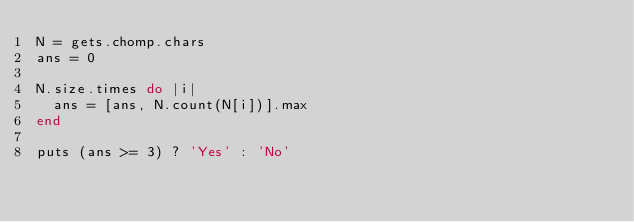Convert code to text. <code><loc_0><loc_0><loc_500><loc_500><_Ruby_>N = gets.chomp.chars
ans = 0

N.size.times do |i|
  ans = [ans, N.count(N[i])].max
end

puts (ans >= 3) ? 'Yes' : 'No'</code> 